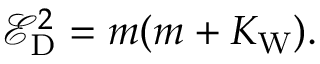Convert formula to latex. <formula><loc_0><loc_0><loc_500><loc_500>\mathcal { E } _ { D } ^ { 2 } = m ( m + K _ { W } ) .</formula> 